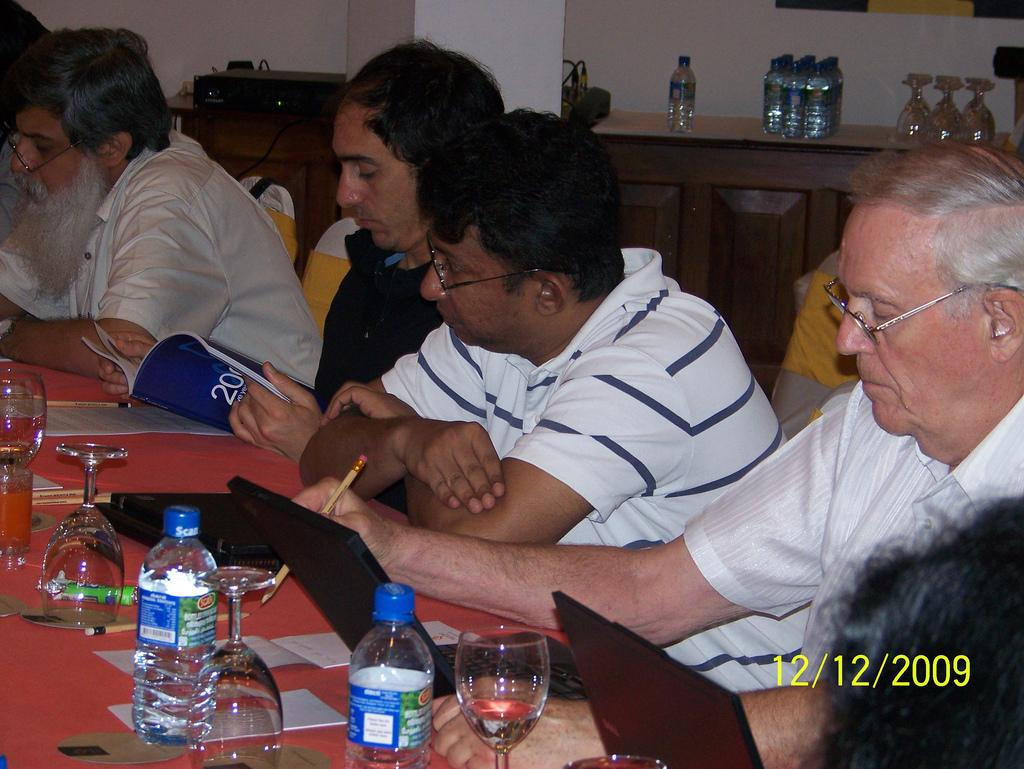What are the persons in the image doing? The persons in the image are sitting on chairs. What is one person holding in the image? One person is holding a book. What is another person holding in the image? One person is holding a pencil. What objects can be seen on the table in the image? There are bottles, glasses, cards, and a laptop on the table. What type of wall can be seen in the image? There is no wall present in the image. What is the mother doing in the image? There is no mention of a mother or any parental figure in the image. 